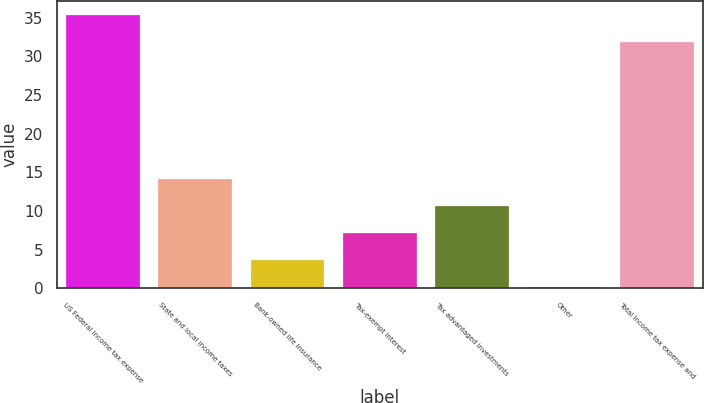Convert chart. <chart><loc_0><loc_0><loc_500><loc_500><bar_chart><fcel>US Federal income tax expense<fcel>State and local income taxes<fcel>Bank-owned life insurance<fcel>Tax-exempt interest<fcel>Tax advantaged investments<fcel>Other<fcel>Total income tax expense and<nl><fcel>35.38<fcel>14.12<fcel>3.68<fcel>7.16<fcel>10.64<fcel>0.2<fcel>31.9<nl></chart> 